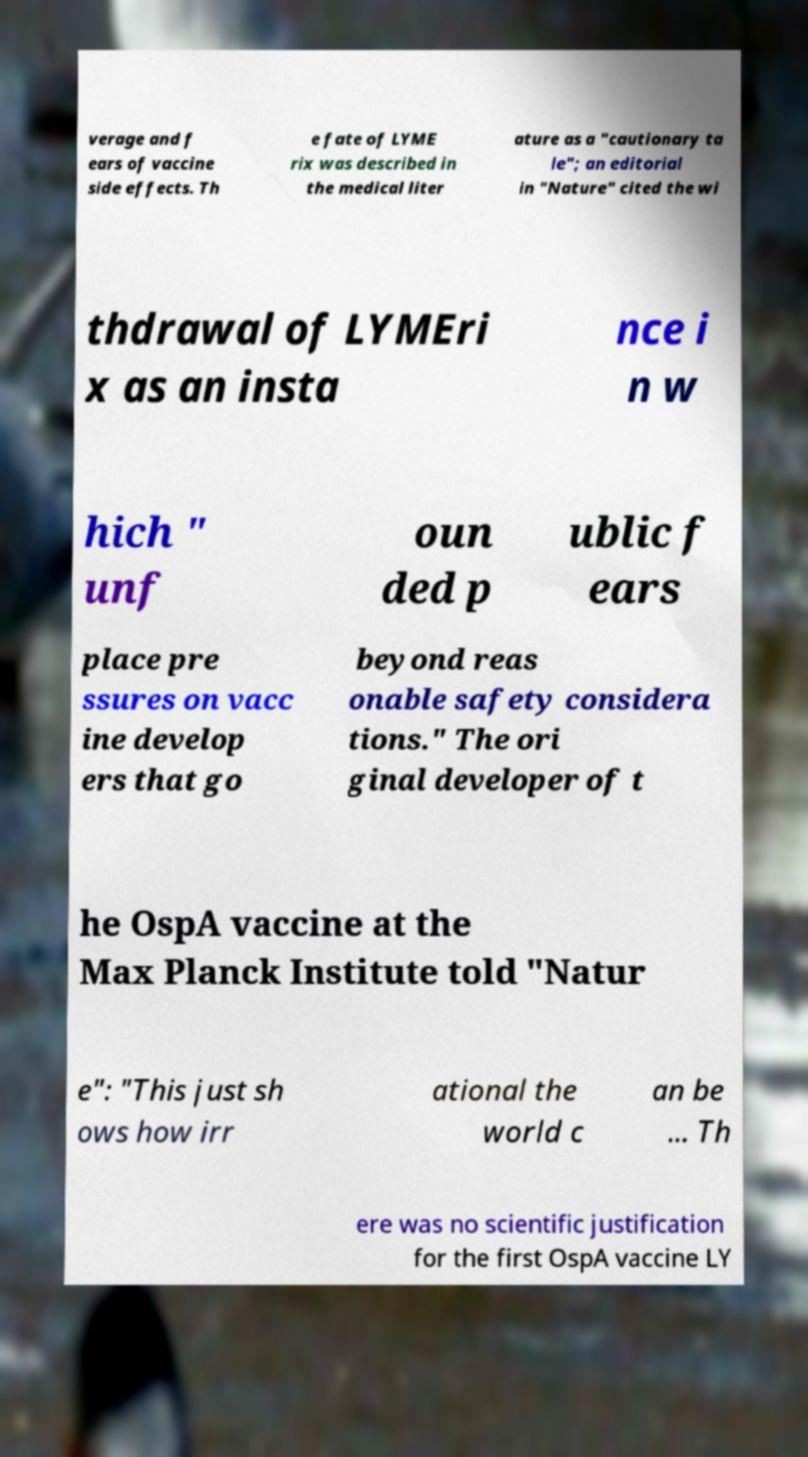Please identify and transcribe the text found in this image. verage and f ears of vaccine side effects. Th e fate of LYME rix was described in the medical liter ature as a "cautionary ta le"; an editorial in "Nature" cited the wi thdrawal of LYMEri x as an insta nce i n w hich " unf oun ded p ublic f ears place pre ssures on vacc ine develop ers that go beyond reas onable safety considera tions." The ori ginal developer of t he OspA vaccine at the Max Planck Institute told "Natur e": "This just sh ows how irr ational the world c an be ... Th ere was no scientific justification for the first OspA vaccine LY 